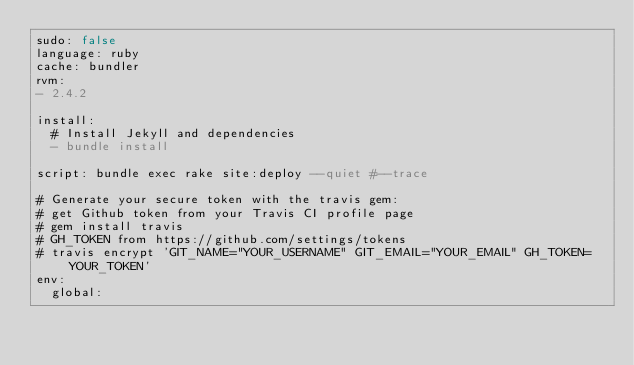<code> <loc_0><loc_0><loc_500><loc_500><_YAML_>sudo: false
language: ruby
cache: bundler
rvm:
- 2.4.2

install:
  # Install Jekyll and dependencies
  - bundle install

script: bundle exec rake site:deploy --quiet #--trace

# Generate your secure token with the travis gem:
# get Github token from your Travis CI profile page
# gem install travis
# GH_TOKEN from https://github.com/settings/tokens
# travis encrypt 'GIT_NAME="YOUR_USERNAME" GIT_EMAIL="YOUR_EMAIL" GH_TOKEN=YOUR_TOKEN'
env:
  global:</code> 